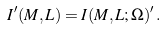Convert formula to latex. <formula><loc_0><loc_0><loc_500><loc_500>I ^ { \prime } ( M , L ) = I ( M , L ; \Omega ) ^ { \prime } \, .</formula> 